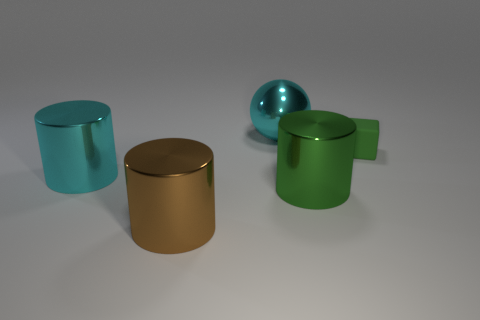Add 3 big cyan matte spheres. How many objects exist? 8 Subtract all cylinders. How many objects are left? 2 Subtract 1 green cylinders. How many objects are left? 4 Subtract all green cylinders. Subtract all big purple rubber objects. How many objects are left? 4 Add 2 matte cubes. How many matte cubes are left? 3 Add 3 green matte blocks. How many green matte blocks exist? 4 